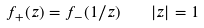Convert formula to latex. <formula><loc_0><loc_0><loc_500><loc_500>f _ { + } ( z ) = f _ { - } ( 1 / z ) \quad | z | = 1</formula> 